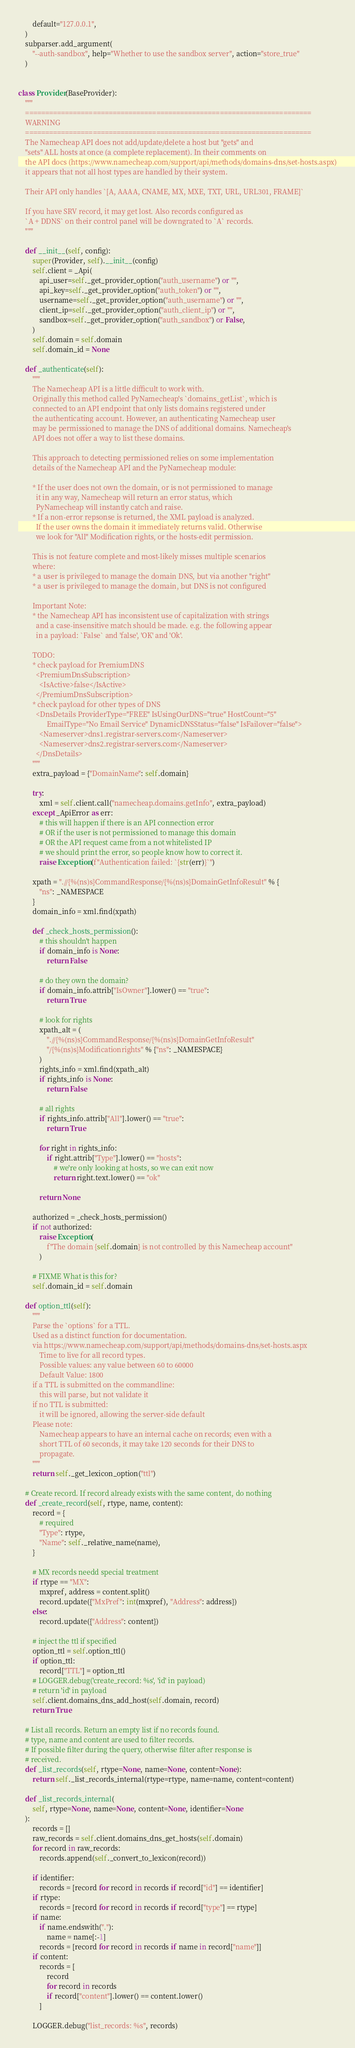Convert code to text. <code><loc_0><loc_0><loc_500><loc_500><_Python_>        default="127.0.0.1",
    )
    subparser.add_argument(
        "--auth-sandbox", help="Whether to use the sandbox server", action="store_true"
    )


class Provider(BaseProvider):
    """
    ========================================================================
    WARNING
    ========================================================================
    The Namecheap API does not add/update/delete a host but "gets" and
    "sets" ALL hosts at once (a complete replacement). In their comments on
    the API docs (https://www.namecheap.com/support/api/methods/domains-dns/set-hosts.aspx)
    it appears that not all host types are handled by their system.

    Their API only handles `[A, AAAA, CNAME, MX, MXE, TXT, URL, URL301, FRAME]`

    If you have SRV record, it may get lost. Also records configured as
    `A + DDNS` on their control panel will be downgrated to `A` records.
    """

    def __init__(self, config):
        super(Provider, self).__init__(config)
        self.client = _Api(
            api_user=self._get_provider_option("auth_username") or "",
            api_key=self._get_provider_option("auth_token") or "",
            username=self._get_provider_option("auth_username") or "",
            client_ip=self._get_provider_option("auth_client_ip") or "",
            sandbox=self._get_provider_option("auth_sandbox") or False,
        )
        self.domain = self.domain
        self.domain_id = None

    def _authenticate(self):
        """
        The Namecheap API is a little difficult to work with.
        Originally this method called PyNamecheap's `domains_getList`, which is
        connected to an API endpoint that only lists domains registered under
        the authenticating account. However, an authenticating Namecheap user
        may be permissioned to manage the DNS of additional domains. Namecheap's
        API does not offer a way to list these domains.

        This approach to detecting permissioned relies on some implementation
        details of the Namecheap API and the PyNamecheap module:

        * If the user does not own the domain, or is not permissioned to manage
          it in any way, Namecheap will return an error status, which
          PyNamecheap will instantly catch and raise.
        * If a non-error repsonse is returned, the XML payload is analyzed.
          If the user owns the domain it immediately returns valid. Otherwise
          we look for "All" Modification rights, or the hosts-edit permission.

        This is not feature complete and most-likely misses multiple scenarios
        where:
        * a user is privileged to manage the domain DNS, but via another "right"
        * a user is privileged to manage the domain, but DNS is not configured

        Important Note:
        * the Namecheap API has inconsistent use of capitalization with strings
          and a case-insensitive match should be made. e.g. the following appear
          in a payload: `False` and 'false', 'OK' and 'Ok'.

        TODO:
        * check payload for PremiumDNS
          <PremiumDnsSubscription>
            <IsActive>false</IsActive>
          </PremiumDnsSubscription>
        * check payload for other types of DNS
          <DnsDetails ProviderType="FREE" IsUsingOurDNS="true" HostCount="5"
                EmailType="No Email Service" DynamicDNSStatus="false" IsFailover="false">
            <Nameserver>dns1.registrar-servers.com</Nameserver>
            <Nameserver>dns2.registrar-servers.com</Nameserver>
          </DnsDetails>
        """
        extra_payload = {"DomainName": self.domain}

        try:
            xml = self.client.call("namecheap.domains.getInfo", extra_payload)
        except _ApiError as err:
            # this will happen if there is an API connection error
            # OR if the user is not permissioned to manage this domain
            # OR the API request came from a not whitelisted IP
            # we should print the error, so people know how to correct it.
            raise Exception(f"Authentication failed: `{str(err)}`")

        xpath = ".//{%(ns)s}CommandResponse/{%(ns)s}DomainGetInfoResult" % {
            "ns": _NAMESPACE
        }
        domain_info = xml.find(xpath)

        def _check_hosts_permission():
            # this shouldn't happen
            if domain_info is None:
                return False

            # do they own the domain?
            if domain_info.attrib["IsOwner"].lower() == "true":
                return True

            # look for rights
            xpath_alt = (
                ".//{%(ns)s}CommandResponse/{%(ns)s}DomainGetInfoResult"
                "/{%(ns)s}Modificationrights" % {"ns": _NAMESPACE}
            )
            rights_info = xml.find(xpath_alt)
            if rights_info is None:
                return False

            # all rights
            if rights_info.attrib["All"].lower() == "true":
                return True

            for right in rights_info:
                if right.attrib["Type"].lower() == "hosts":
                    # we're only looking at hosts, so we can exit now
                    return right.text.lower() == "ok"

            return None

        authorized = _check_hosts_permission()
        if not authorized:
            raise Exception(
                f"The domain {self.domain} is not controlled by this Namecheap account"
            )

        # FIXME What is this for?
        self.domain_id = self.domain

    def option_ttl(self):
        """
        Parse the `options` for a TTL.
        Used as a distinct function for documentation.
        via https://www.namecheap.com/support/api/methods/domains-dns/set-hosts.aspx
            Time to live for all record types.
            Possible values: any value between 60 to 60000
            Default Value: 1800
        if a TTL is submitted on the commandline:
            this will parse, but not validate it
        if no TTL is submitted:
            it will be ignored, allowing the server-side default
        Please note:
            Namecheap appears to have an internal cache on records; even with a
            short TTL of 60 seconds, it may take 120 seconds for their DNS to
            propagate.
        """
        return self._get_lexicon_option("ttl")

    # Create record. If record already exists with the same content, do nothing
    def _create_record(self, rtype, name, content):
        record = {
            # required
            "Type": rtype,
            "Name": self._relative_name(name),
        }

        # MX records needd special treatment
        if rtype == "MX":
            mxpref, address = content.split()
            record.update({"MxPref": int(mxpref), "Address": address})
        else:
            record.update({"Address": content})

        # inject the ttl if specified
        option_ttl = self.option_ttl()
        if option_ttl:
            record["TTL"] = option_ttl
        # LOGGER.debug('create_record: %s', 'id' in payload)
        # return 'id' in payload
        self.client.domains_dns_add_host(self.domain, record)
        return True

    # List all records. Return an empty list if no records found.
    # type, name and content are used to filter records.
    # If possible filter during the query, otherwise filter after response is
    # received.
    def _list_records(self, rtype=None, name=None, content=None):
        return self._list_records_internal(rtype=rtype, name=name, content=content)

    def _list_records_internal(
        self, rtype=None, name=None, content=None, identifier=None
    ):
        records = []
        raw_records = self.client.domains_dns_get_hosts(self.domain)
        for record in raw_records:
            records.append(self._convert_to_lexicon(record))

        if identifier:
            records = [record for record in records if record["id"] == identifier]
        if rtype:
            records = [record for record in records if record["type"] == rtype]
        if name:
            if name.endswith("."):
                name = name[:-1]
            records = [record for record in records if name in record["name"]]
        if content:
            records = [
                record
                for record in records
                if record["content"].lower() == content.lower()
            ]

        LOGGER.debug("list_records: %s", records)</code> 